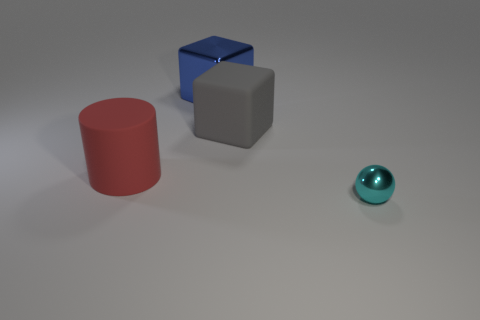What shapes can you see in the image? The image displays a collection of geometric shapes: a red cylinder on the left, a blue cube in the center, and a gray cube behind the blue one. Additionally, there's a shiny cyan sphere. 